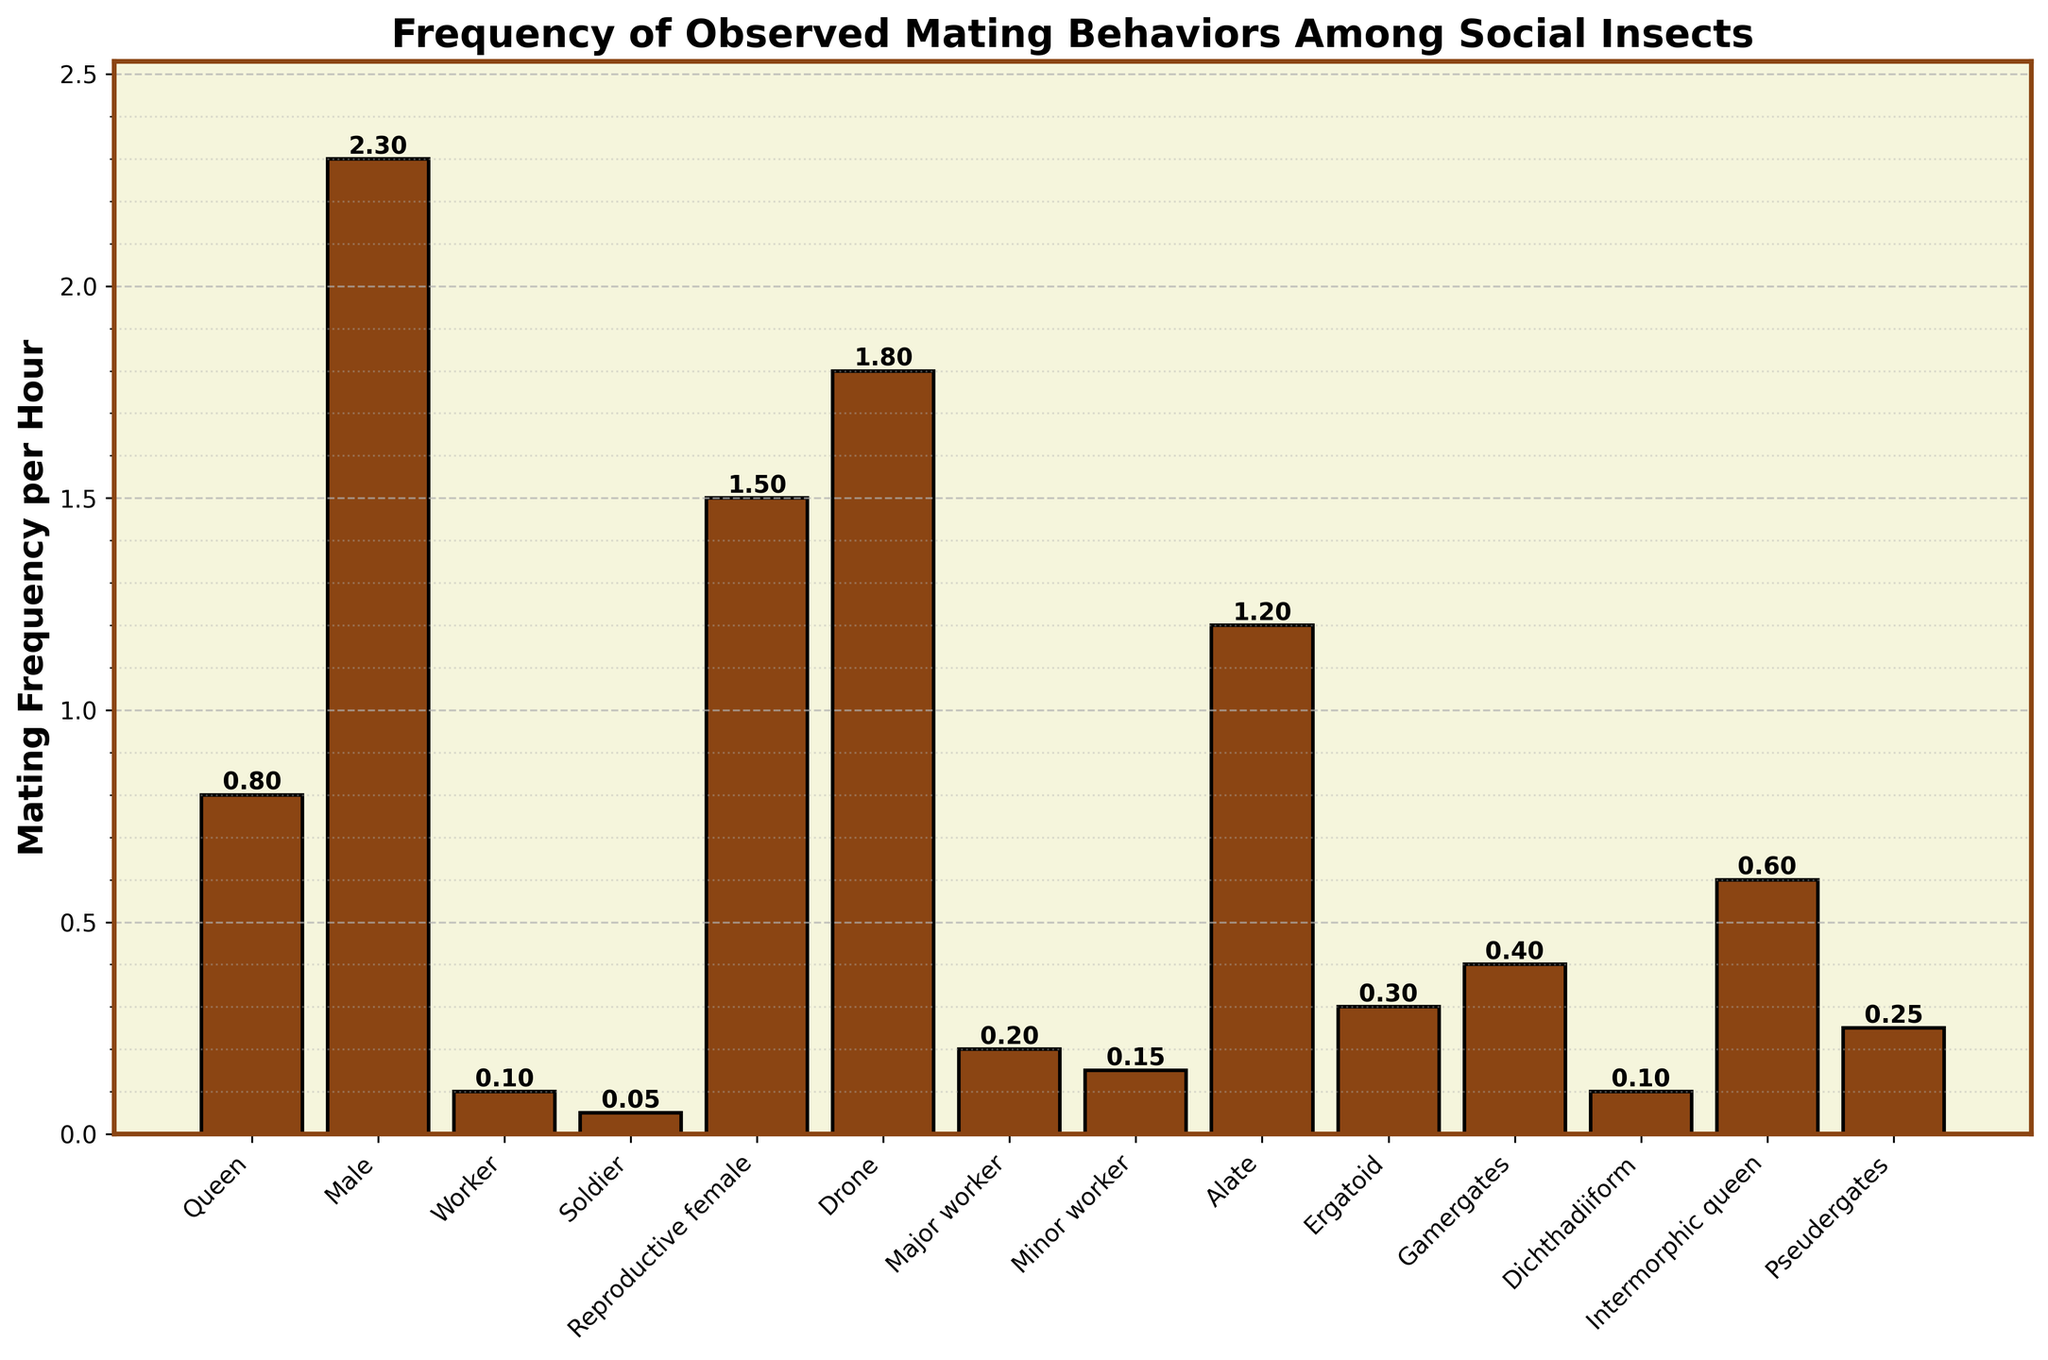Which caste has the highest mating frequency per hour? To determine which caste has the highest mating frequency per hour, observe the bar that extends the highest along the y-axis, representing mating frequency per hour.
Answer: Male What is the difference in mating frequency per hour between the reproductive female and the queen? To find the difference, subtract the mating frequency of the queen (0.8) from the mating frequency of the reproductive female (1.5). 1.5 - 0.8 = 0.7
Answer: 0.7 Which caste(s) have a mating frequency per hour greater than 1.0? To identify these castes, look for bars that reach above the 1.0 mark on the y-axis. These castes are reproductive female (1.5), male (2.3), alate (1.2), and drone (1.8).
Answer: Reproductive female, male, alate, drone What is the average mating frequency per hour of the worker, soldier, and major worker castes? Add the mating frequencies of worker (0.1), soldier (0.05), and major worker (0.2) and divide by the number of castes (3). (0.1 + 0.05 + 0.2) / 3 = 0.1167
Answer: 0.1167 Which castes have a mating frequency that is less than or equal to 0.1? Find bars that do not exceed the 0.1 mark on the y-axis. These castes are worker (0.1), soldier (0.05), dichthadiiform (0.1), and minor worker (0.15) *among others*.
Answer: Worker, soldier, dichthadiiform, minor worker How much taller is the bar for males compared to drones? Find the height difference by subtracting the mating frequency of drones (1.8) from that of males (2.3). 2.3 - 1.8 = 0.5
Answer: 0.5 Calculate the median mating frequency per hour of all the castes listed. To find the median, first order the frequencies: [0.05, 0.1, 0.1, 0.15, 0.2, 0.25, 0.3, 0.4, 0.6, 0.8, 1.2, 1.5, 1.8, 2.3]. The median is the middle value, which is the average of the 7th and 8th values: (0.3 + 0.4) / 2 = 0.35
Answer: 0.35 Which caste has the bar that is precisely half the height of the reproductive female's bar? The reproductive female's bar is at 1.5. Half of this is 0.75. The caste closest to this value is the Queen, with 0.8.
Answer: Queen What is the sum of the mating frequencies for the reproductive female, drone, and alate? Add the frequencies of reproductive female (1.5), drone (1.8), and alate (1.2). 1.5 + 1.8 + 1.2 = 4.5
Answer: 4.5 Who has higher mating frequency per hour, the queen or the gamergates caste? Compare the lengths visually: Queen (0.8) is higher than Gamergates (0.4).
Answer: Queen 